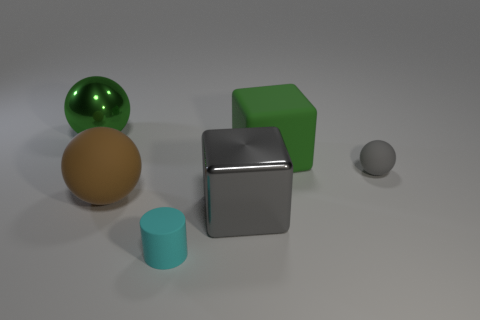Add 1 large green spheres. How many objects exist? 7 Subtract all cylinders. How many objects are left? 5 Subtract all gray metallic cubes. Subtract all big metallic blocks. How many objects are left? 4 Add 2 gray matte spheres. How many gray matte spheres are left? 3 Add 6 gray rubber things. How many gray rubber things exist? 7 Subtract 1 brown spheres. How many objects are left? 5 